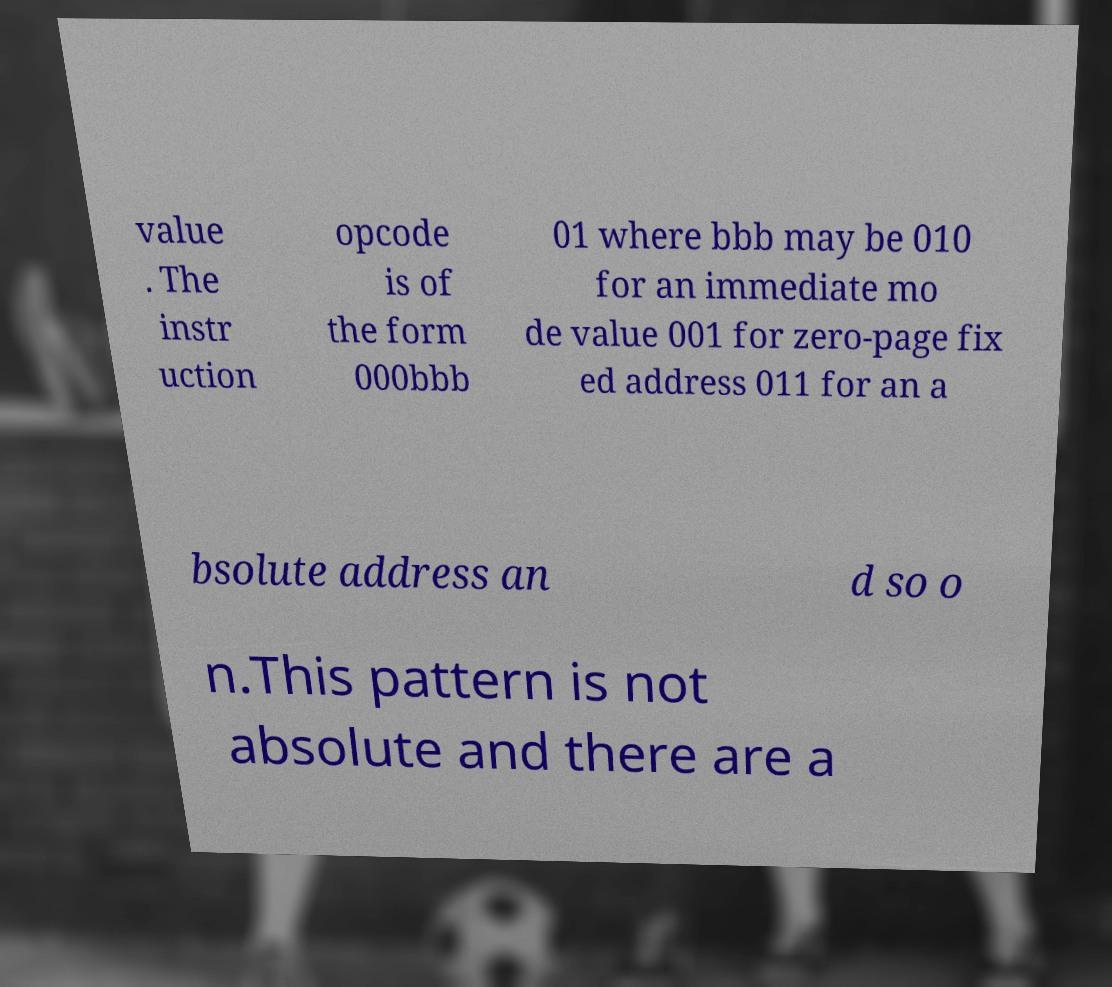I need the written content from this picture converted into text. Can you do that? value . The instr uction opcode is of the form 000bbb 01 where bbb may be 010 for an immediate mo de value 001 for zero-page fix ed address 011 for an a bsolute address an d so o n.This pattern is not absolute and there are a 